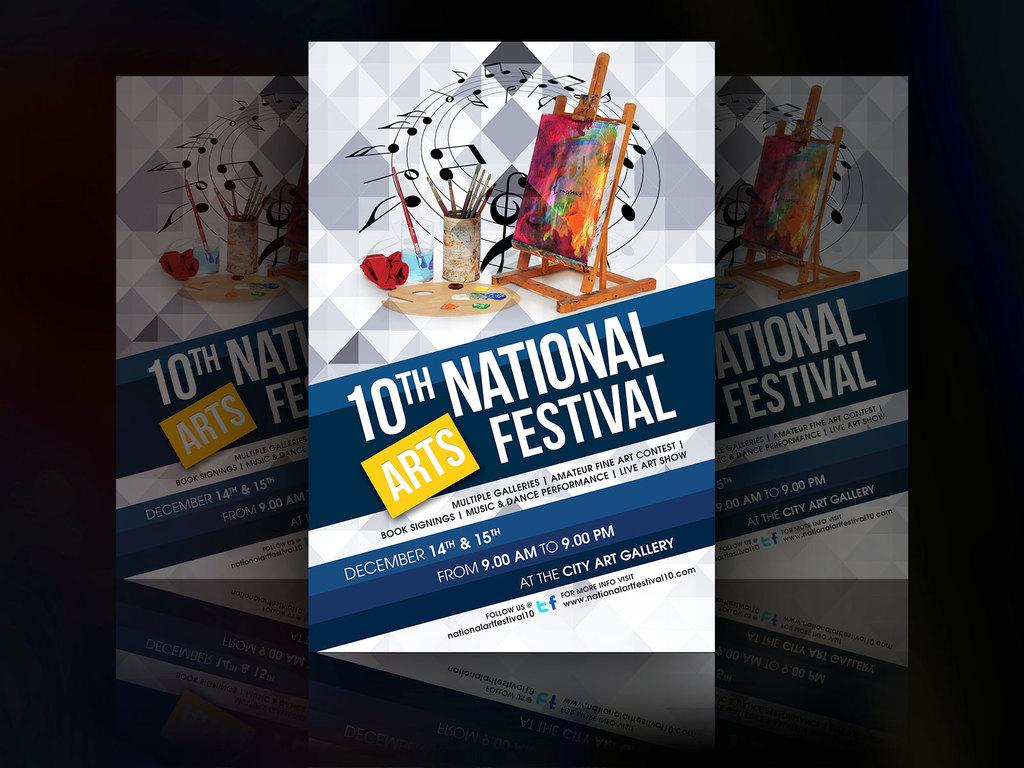<image>
Provide a brief description of the given image. National festival for arts poster for the tenth arts 